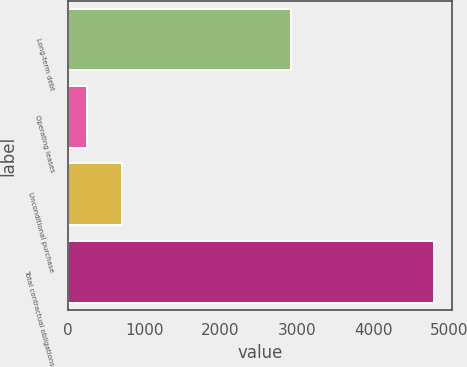Convert chart. <chart><loc_0><loc_0><loc_500><loc_500><bar_chart><fcel>Long-term debt<fcel>Operating leases<fcel>Unconditional purchase<fcel>Total contractual obligations<nl><fcel>2919<fcel>249<fcel>703.4<fcel>4793<nl></chart> 